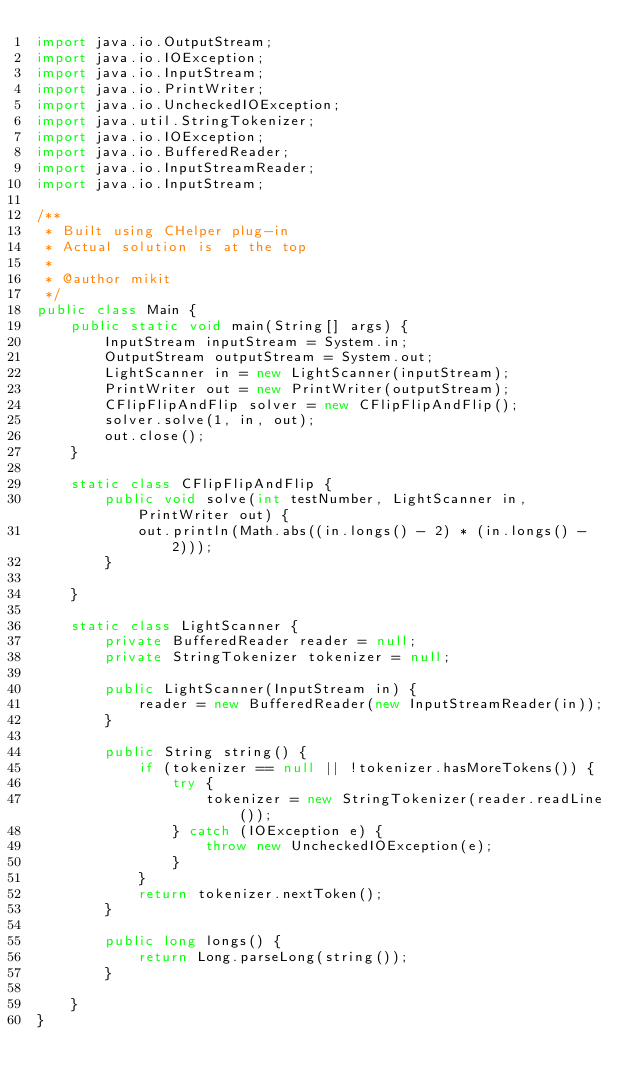Convert code to text. <code><loc_0><loc_0><loc_500><loc_500><_Java_>import java.io.OutputStream;
import java.io.IOException;
import java.io.InputStream;
import java.io.PrintWriter;
import java.io.UncheckedIOException;
import java.util.StringTokenizer;
import java.io.IOException;
import java.io.BufferedReader;
import java.io.InputStreamReader;
import java.io.InputStream;

/**
 * Built using CHelper plug-in
 * Actual solution is at the top
 *
 * @author mikit
 */
public class Main {
    public static void main(String[] args) {
        InputStream inputStream = System.in;
        OutputStream outputStream = System.out;
        LightScanner in = new LightScanner(inputStream);
        PrintWriter out = new PrintWriter(outputStream);
        CFlipFlipAndFlip solver = new CFlipFlipAndFlip();
        solver.solve(1, in, out);
        out.close();
    }

    static class CFlipFlipAndFlip {
        public void solve(int testNumber, LightScanner in, PrintWriter out) {
            out.println(Math.abs((in.longs() - 2) * (in.longs() - 2)));
        }

    }

    static class LightScanner {
        private BufferedReader reader = null;
        private StringTokenizer tokenizer = null;

        public LightScanner(InputStream in) {
            reader = new BufferedReader(new InputStreamReader(in));
        }

        public String string() {
            if (tokenizer == null || !tokenizer.hasMoreTokens()) {
                try {
                    tokenizer = new StringTokenizer(reader.readLine());
                } catch (IOException e) {
                    throw new UncheckedIOException(e);
                }
            }
            return tokenizer.nextToken();
        }

        public long longs() {
            return Long.parseLong(string());
        }

    }
}

</code> 